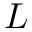<formula> <loc_0><loc_0><loc_500><loc_500>L</formula> 